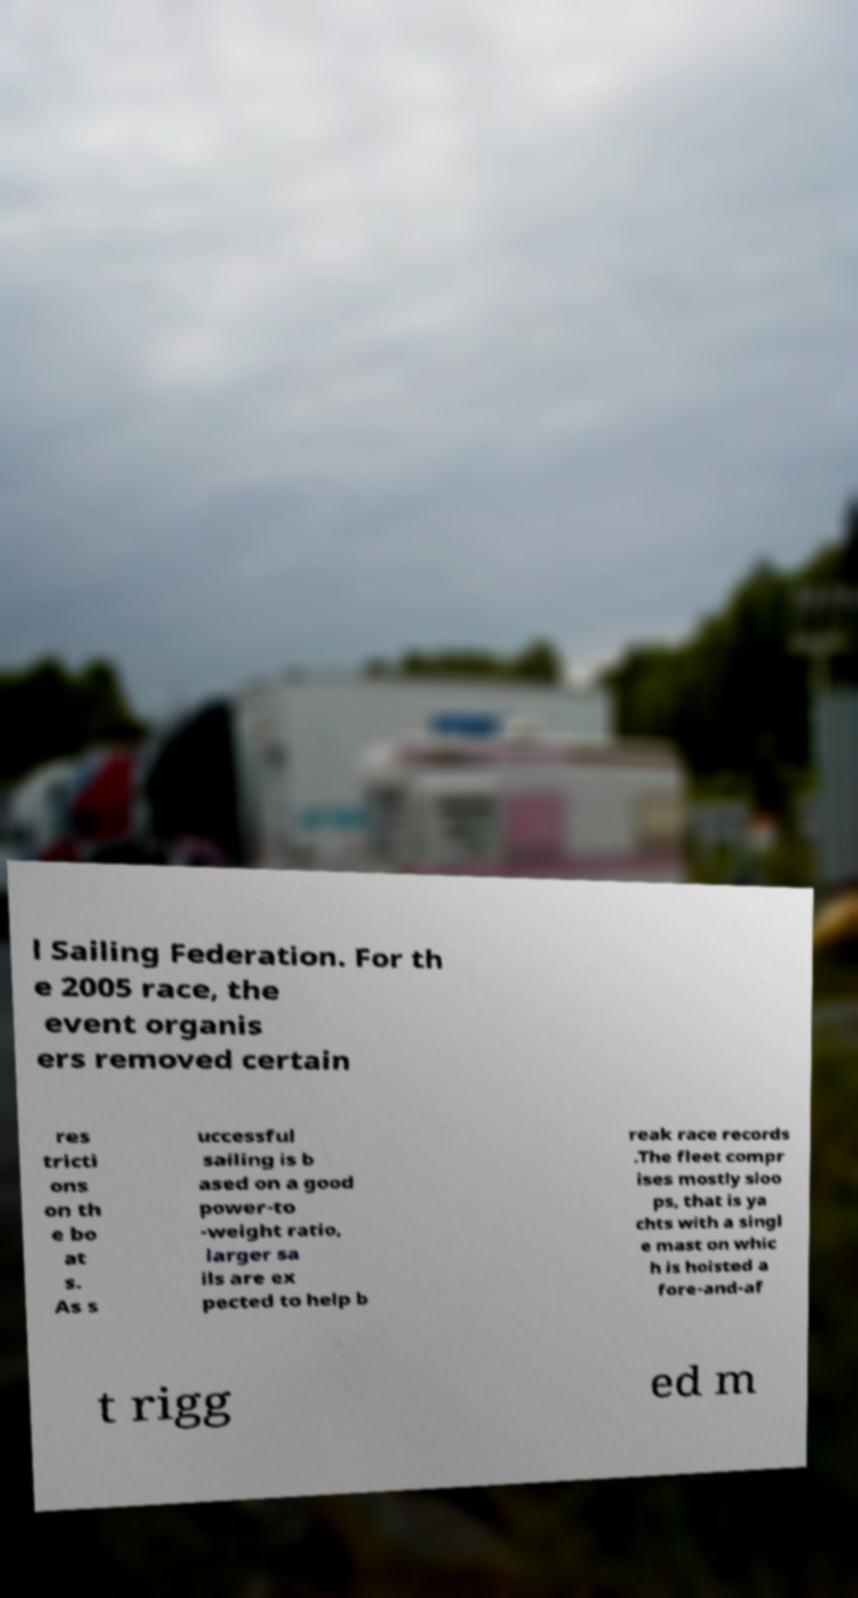Could you assist in decoding the text presented in this image and type it out clearly? l Sailing Federation. For th e 2005 race, the event organis ers removed certain res tricti ons on th e bo at s. As s uccessful sailing is b ased on a good power-to -weight ratio, larger sa ils are ex pected to help b reak race records .The fleet compr ises mostly sloo ps, that is ya chts with a singl e mast on whic h is hoisted a fore-and-af t rigg ed m 